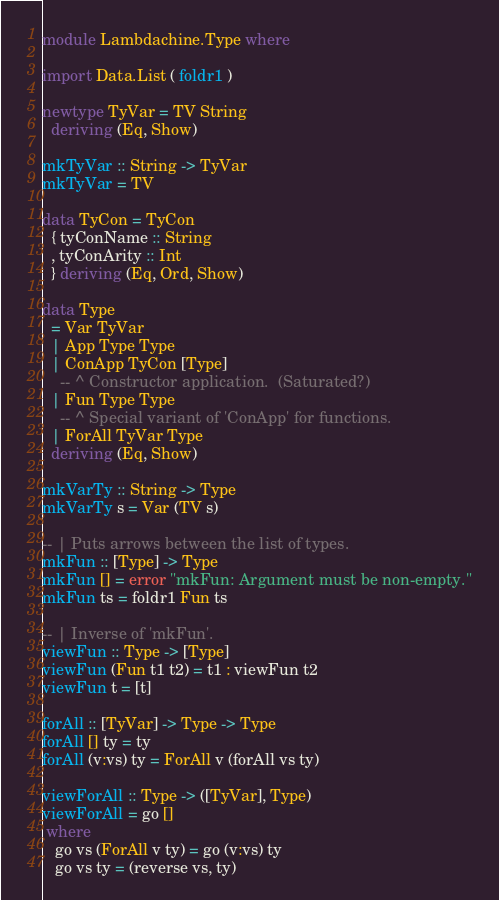Convert code to text. <code><loc_0><loc_0><loc_500><loc_500><_Haskell_>module Lambdachine.Type where

import Data.List ( foldr1 )

newtype TyVar = TV String
  deriving (Eq, Show)

mkTyVar :: String -> TyVar
mkTyVar = TV

data TyCon = TyCon
  { tyConName :: String
  , tyConArity :: Int
  } deriving (Eq, Ord, Show)

data Type
  = Var TyVar
  | App Type Type
  | ConApp TyCon [Type]
    -- ^ Constructor application.  (Saturated?)
  | Fun Type Type
    -- ^ Special variant of 'ConApp' for functions.
  | ForAll TyVar Type
  deriving (Eq, Show)

mkVarTy :: String -> Type
mkVarTy s = Var (TV s)

-- | Puts arrows between the list of types.
mkFun :: [Type] -> Type
mkFun [] = error "mkFun: Argument must be non-empty."
mkFun ts = foldr1 Fun ts

-- | Inverse of 'mkFun'.
viewFun :: Type -> [Type]
viewFun (Fun t1 t2) = t1 : viewFun t2
viewFun t = [t]

forAll :: [TyVar] -> Type -> Type
forAll [] ty = ty
forAll (v:vs) ty = ForAll v (forAll vs ty)

viewForAll :: Type -> ([TyVar], Type)
viewForAll = go []
 where
   go vs (ForAll v ty) = go (v:vs) ty
   go vs ty = (reverse vs, ty)

</code> 